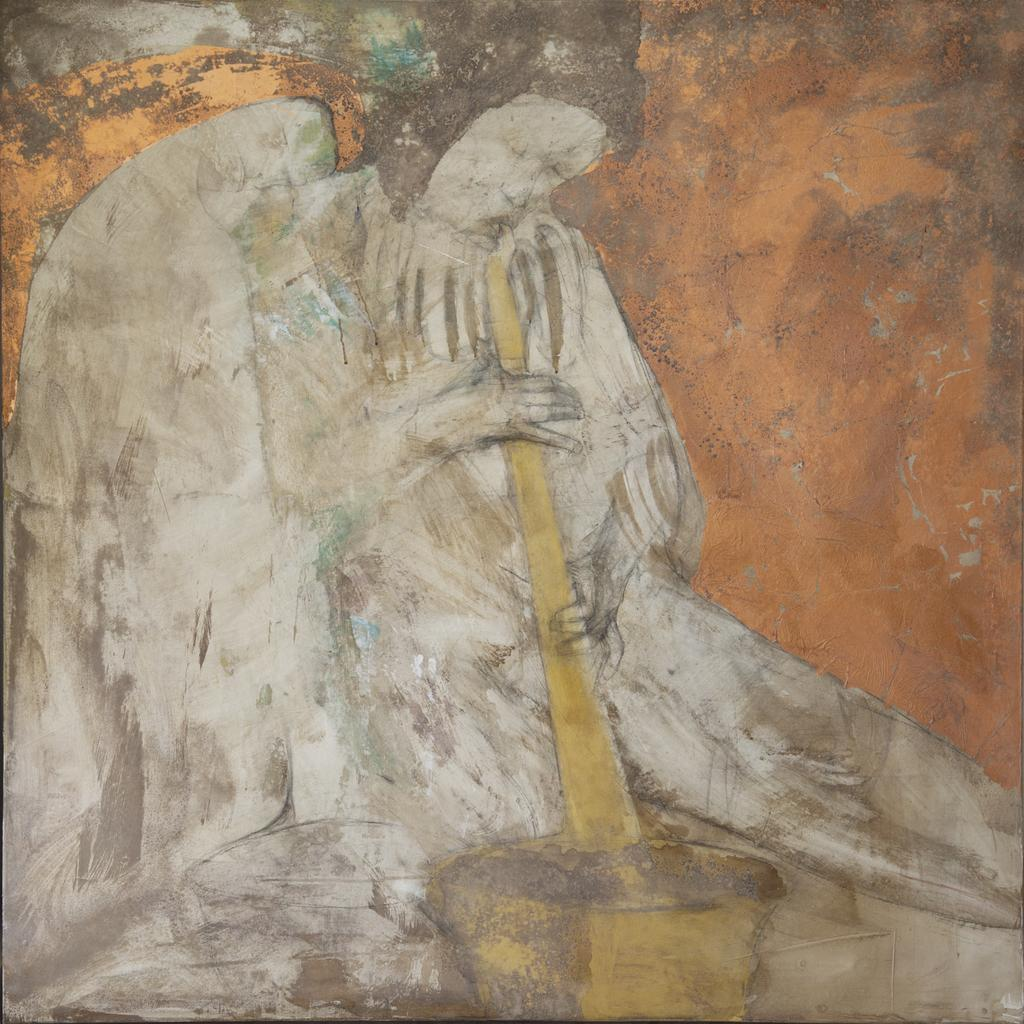What type of art is depicted in the image? There is a person's art in the image. What colors are used in the art? The art uses yellow, white, and brown colors. What is the person holding in the image? The person is holding something in the image, but we cannot determine what it is from the provided facts. What does the person's uncle think about the art in the image? There is no information about the person's uncle or their opinion on the art in the image, as it is not mentioned in the provided facts. 